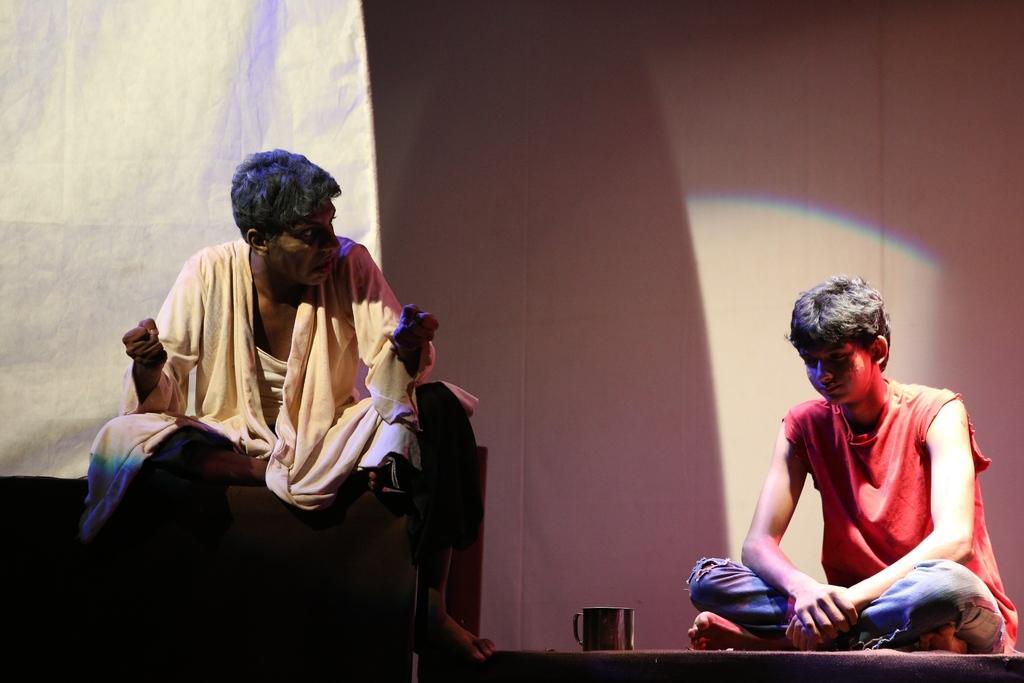Describe this image in one or two sentences. In this image we can see a boy sitting on floor. Near to that there is a cup. On the right side there is another person sitting. In the back there is a wall. Also there is a white color sheet in the back. 